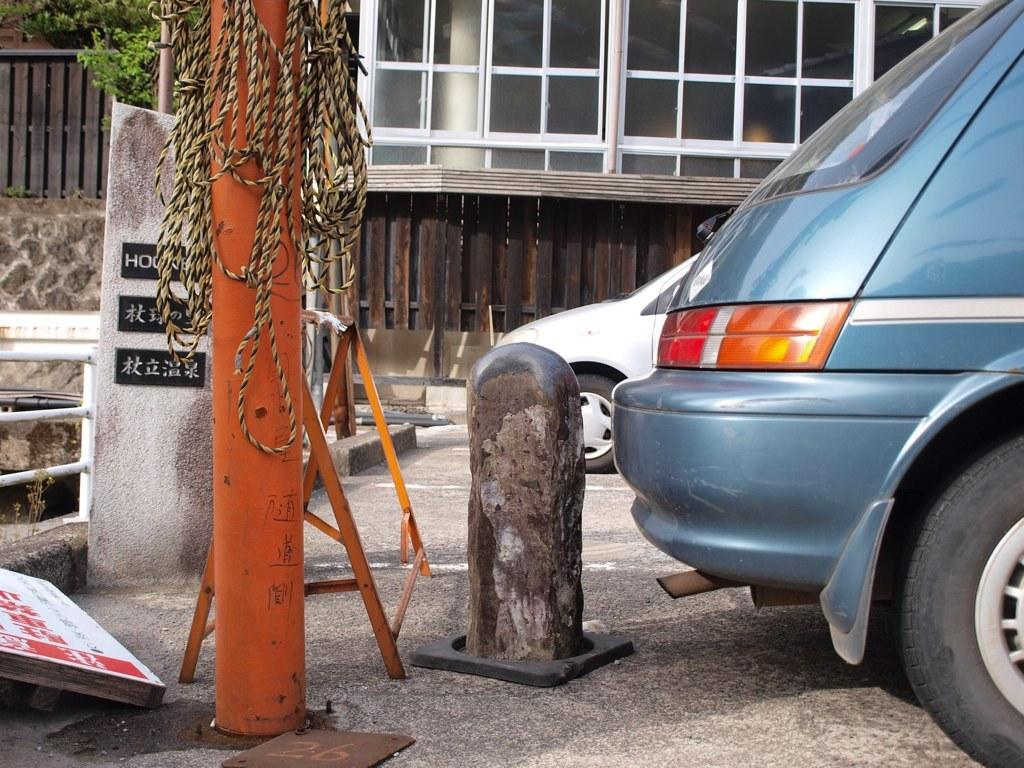What type of vehicles can be seen in the image? There are cars in the image. What else is present in the image besides the cars? There is a banner, a water pipe, a tree, and a building in the image. Can you see a yak grazing in the image? No, there is no yak present in the image. 